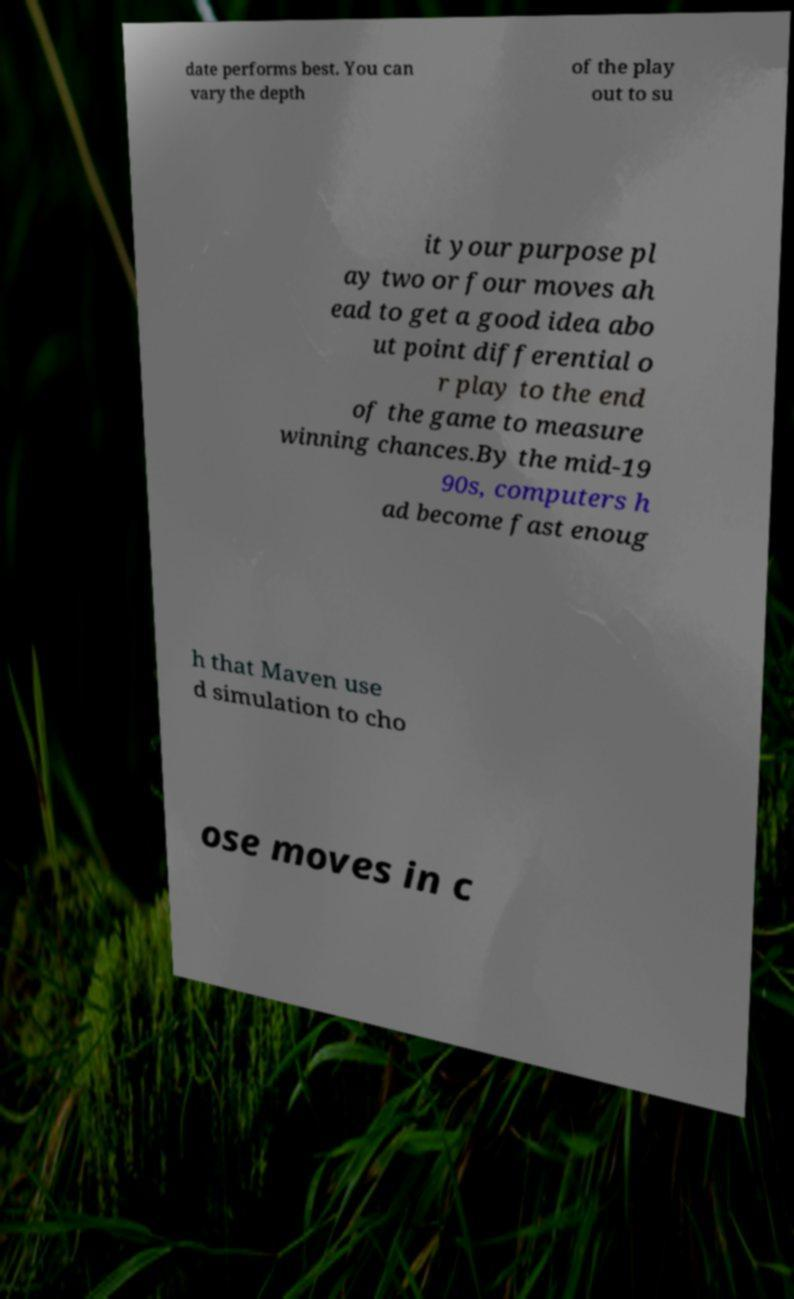What messages or text are displayed in this image? I need them in a readable, typed format. date performs best. You can vary the depth of the play out to su it your purpose pl ay two or four moves ah ead to get a good idea abo ut point differential o r play to the end of the game to measure winning chances.By the mid-19 90s, computers h ad become fast enoug h that Maven use d simulation to cho ose moves in c 